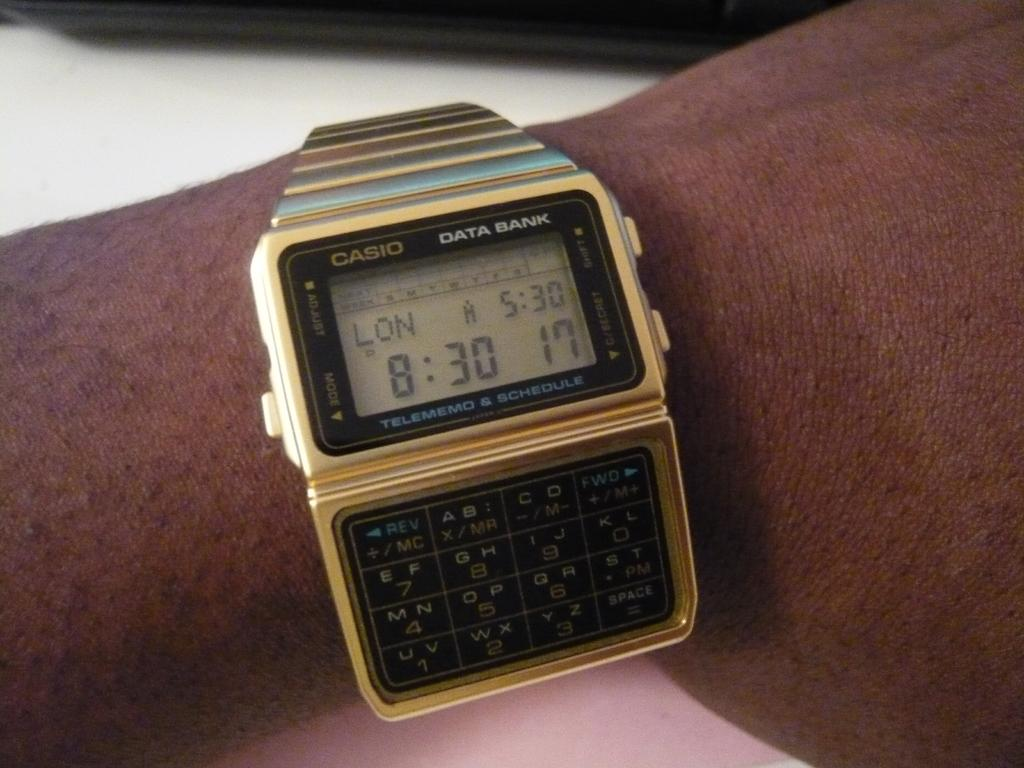<image>
Present a compact description of the photo's key features. A  watch has the Casio logo and a digital screen. 